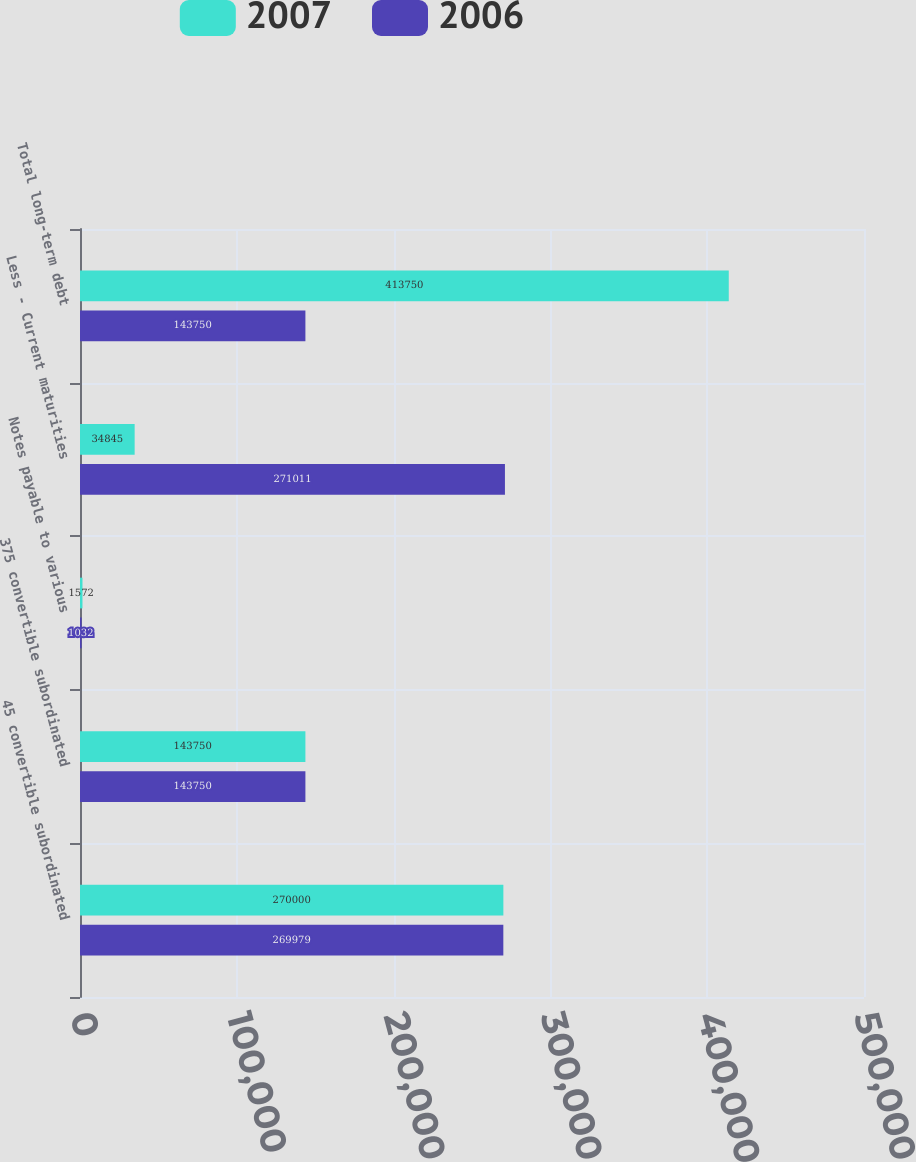Convert chart to OTSL. <chart><loc_0><loc_0><loc_500><loc_500><stacked_bar_chart><ecel><fcel>45 convertible subordinated<fcel>375 convertible subordinated<fcel>Notes payable to various<fcel>Less - Current maturities<fcel>Total long-term debt<nl><fcel>2007<fcel>270000<fcel>143750<fcel>1572<fcel>34845<fcel>413750<nl><fcel>2006<fcel>269979<fcel>143750<fcel>1032<fcel>271011<fcel>143750<nl></chart> 